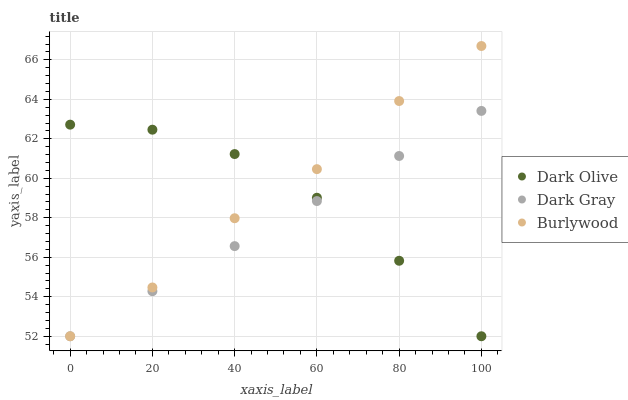Does Dark Gray have the minimum area under the curve?
Answer yes or no. Yes. Does Burlywood have the maximum area under the curve?
Answer yes or no. Yes. Does Dark Olive have the minimum area under the curve?
Answer yes or no. No. Does Dark Olive have the maximum area under the curve?
Answer yes or no. No. Is Dark Gray the smoothest?
Answer yes or no. Yes. Is Burlywood the roughest?
Answer yes or no. Yes. Is Dark Olive the smoothest?
Answer yes or no. No. Is Dark Olive the roughest?
Answer yes or no. No. Does Dark Gray have the lowest value?
Answer yes or no. Yes. Does Burlywood have the highest value?
Answer yes or no. Yes. Does Dark Olive have the highest value?
Answer yes or no. No. Does Dark Olive intersect Burlywood?
Answer yes or no. Yes. Is Dark Olive less than Burlywood?
Answer yes or no. No. Is Dark Olive greater than Burlywood?
Answer yes or no. No. 